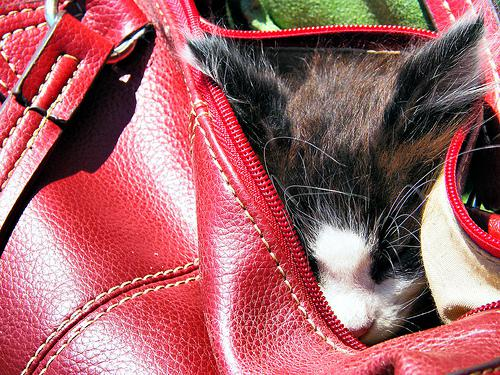Question: what is in the bag?
Choices:
A. A dog.
B. Groceries.
C. A phone.
D. A cat.
Answer with the letter. Answer: D Question: how many cats are in the bag?
Choices:
A. 7.
B. 1.
C. 8.
D. 9.
Answer with the letter. Answer: B Question: where is the cat?
Choices:
A. In the yard.
B. In the bed.
C. In the chair.
D. In the bag.
Answer with the letter. Answer: D Question: what color are the cat's whiskers?
Choices:
A. Red.
B. Blue.
C. White.
D. Orange.
Answer with the letter. Answer: C Question: how does the bag open and close?
Choices:
A. Button.
B. String.
C. Rope.
D. A zipper.
Answer with the letter. Answer: D Question: how many ears are sticking out of the bag?
Choices:
A. 2.
B. 7.
C. 8.
D. 9.
Answer with the letter. Answer: A 